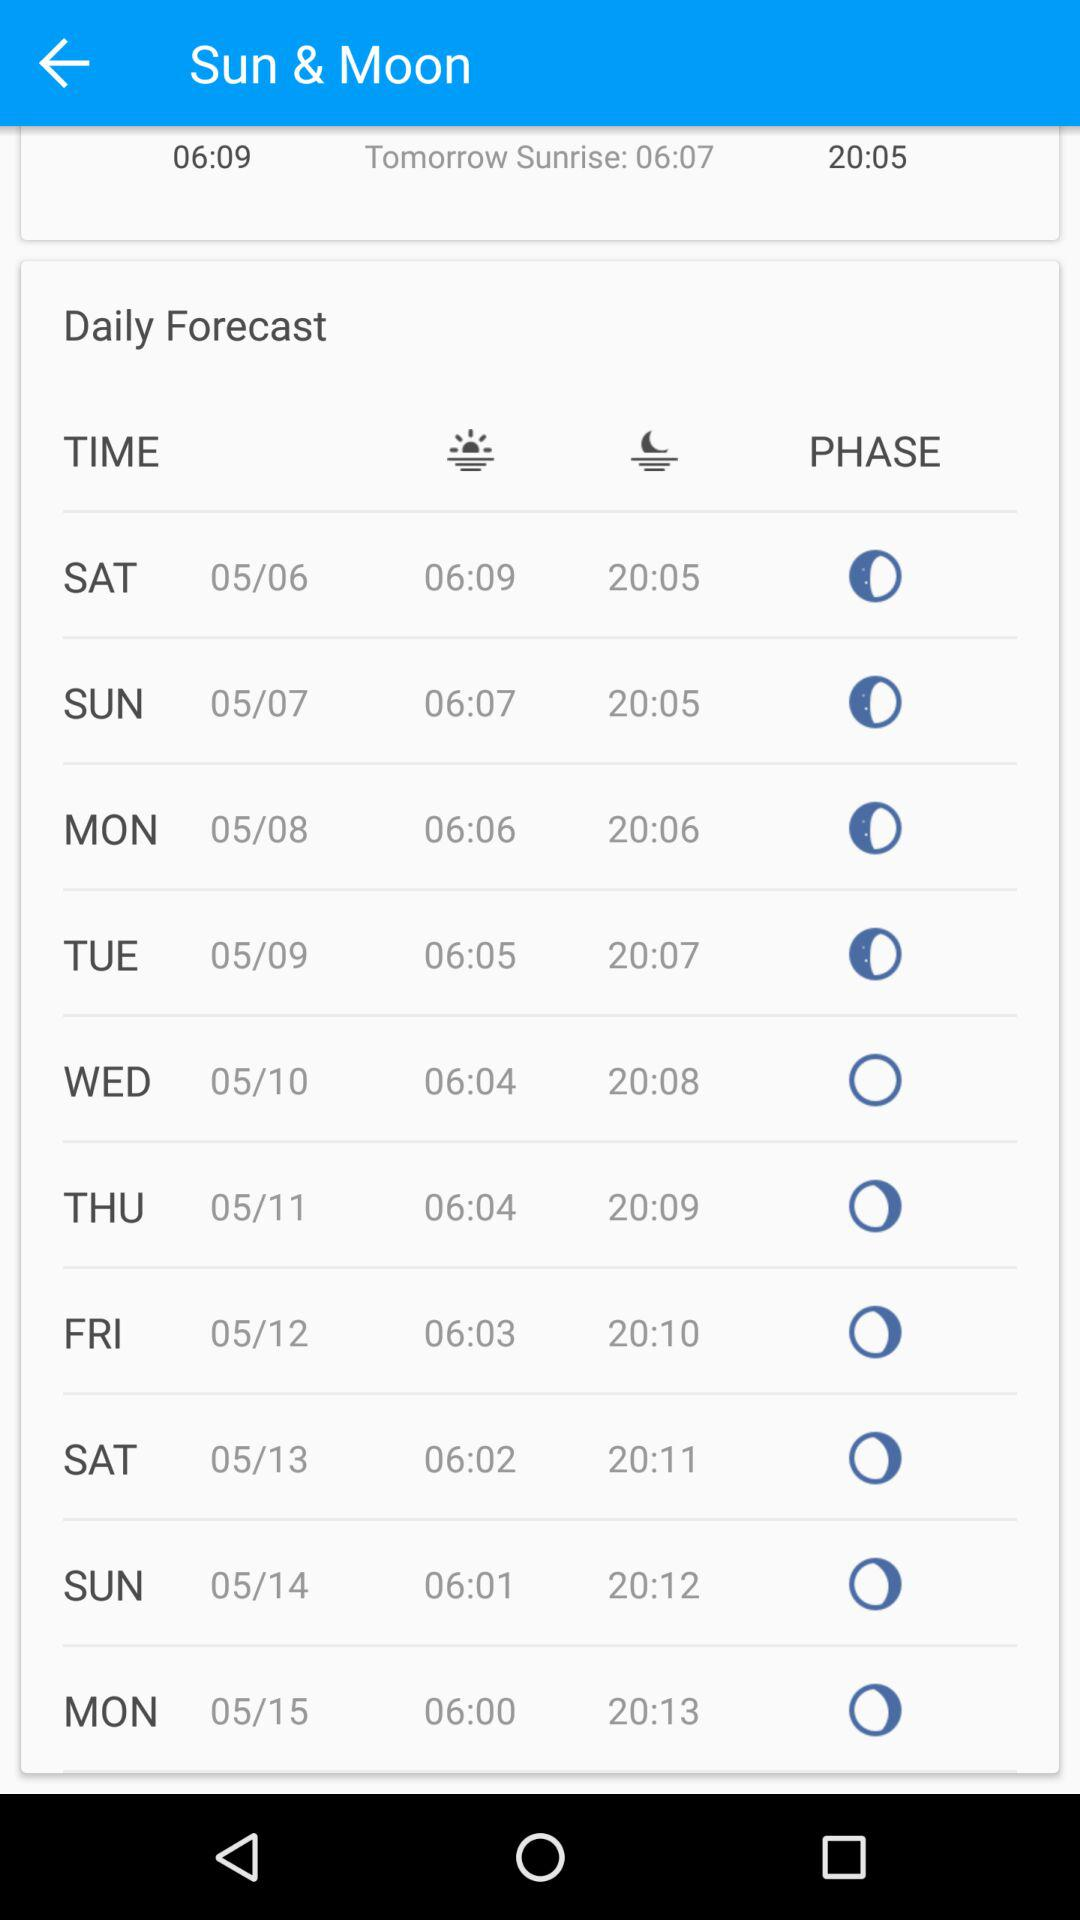How many days are there between today and the day after tomorrow?
Answer the question using a single word or phrase. 2 